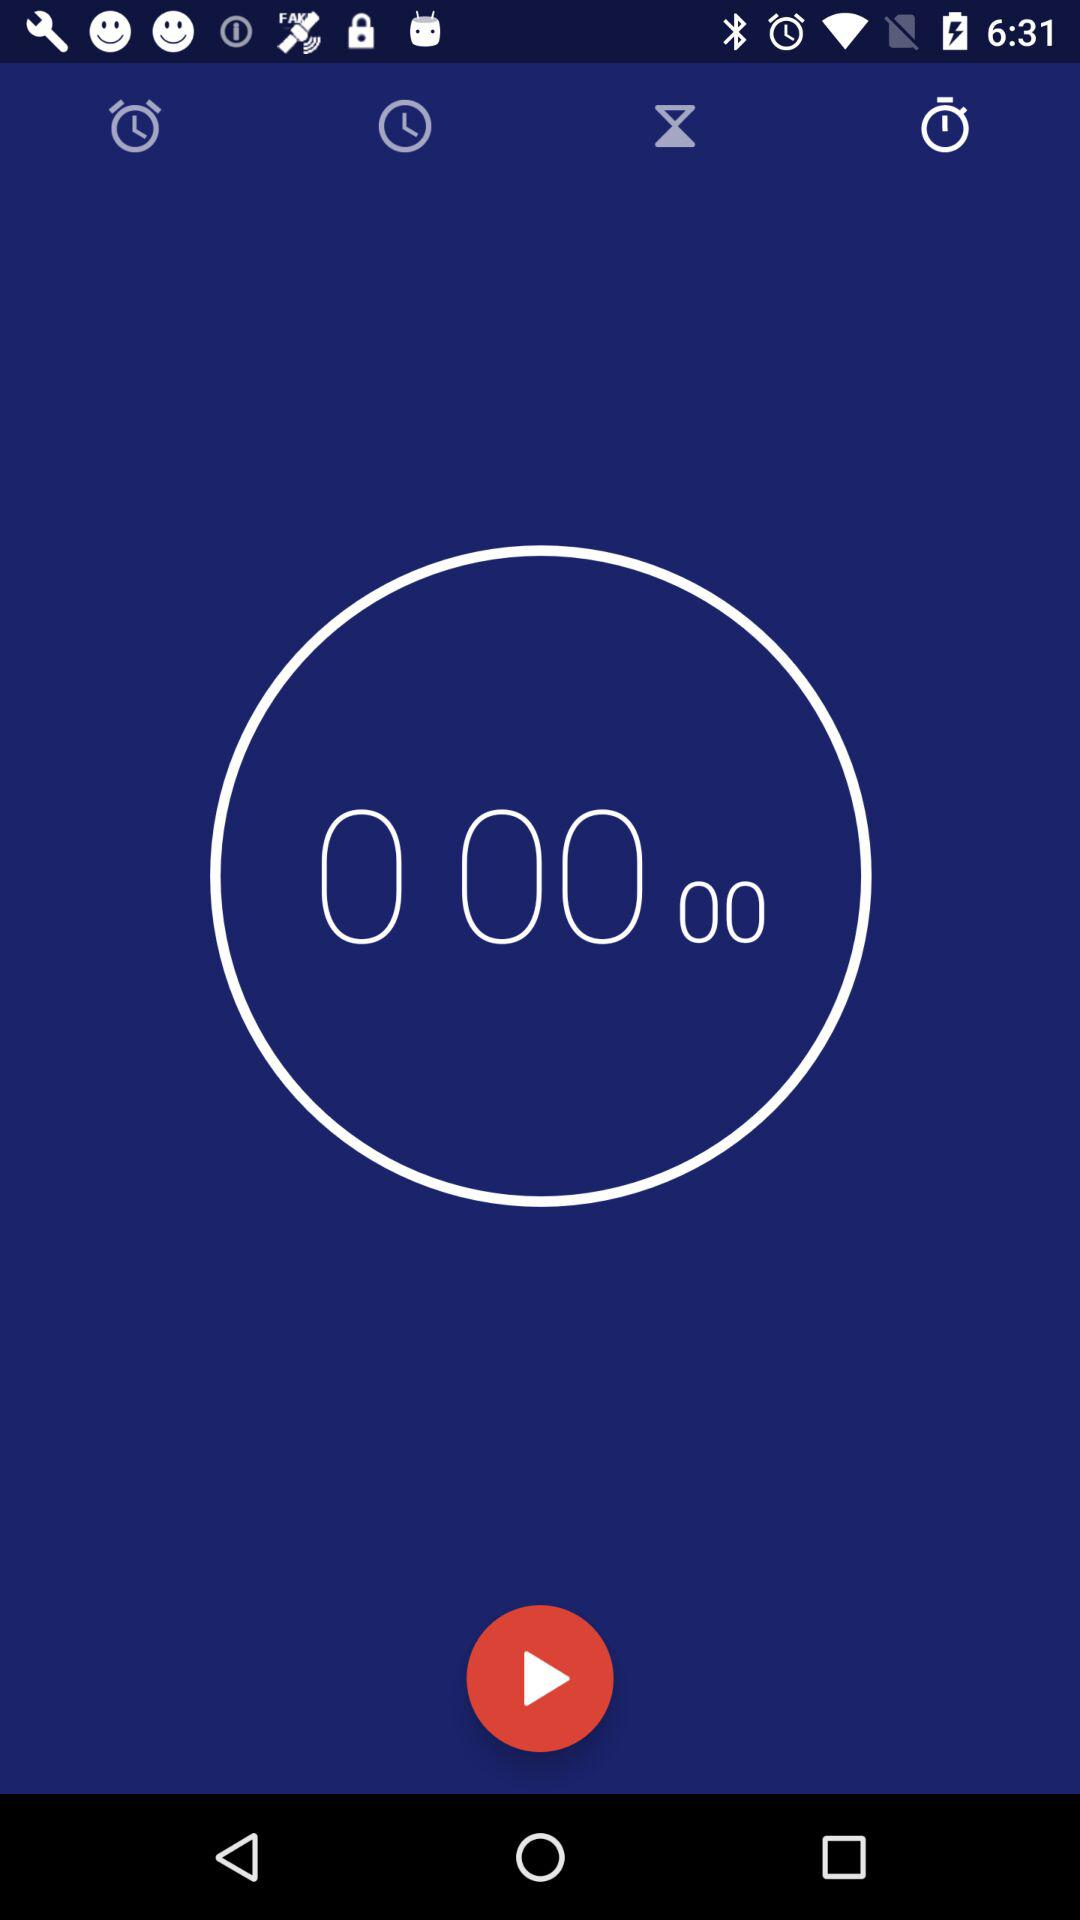Which tab is selected? The selected tab is "Stopwatch". 